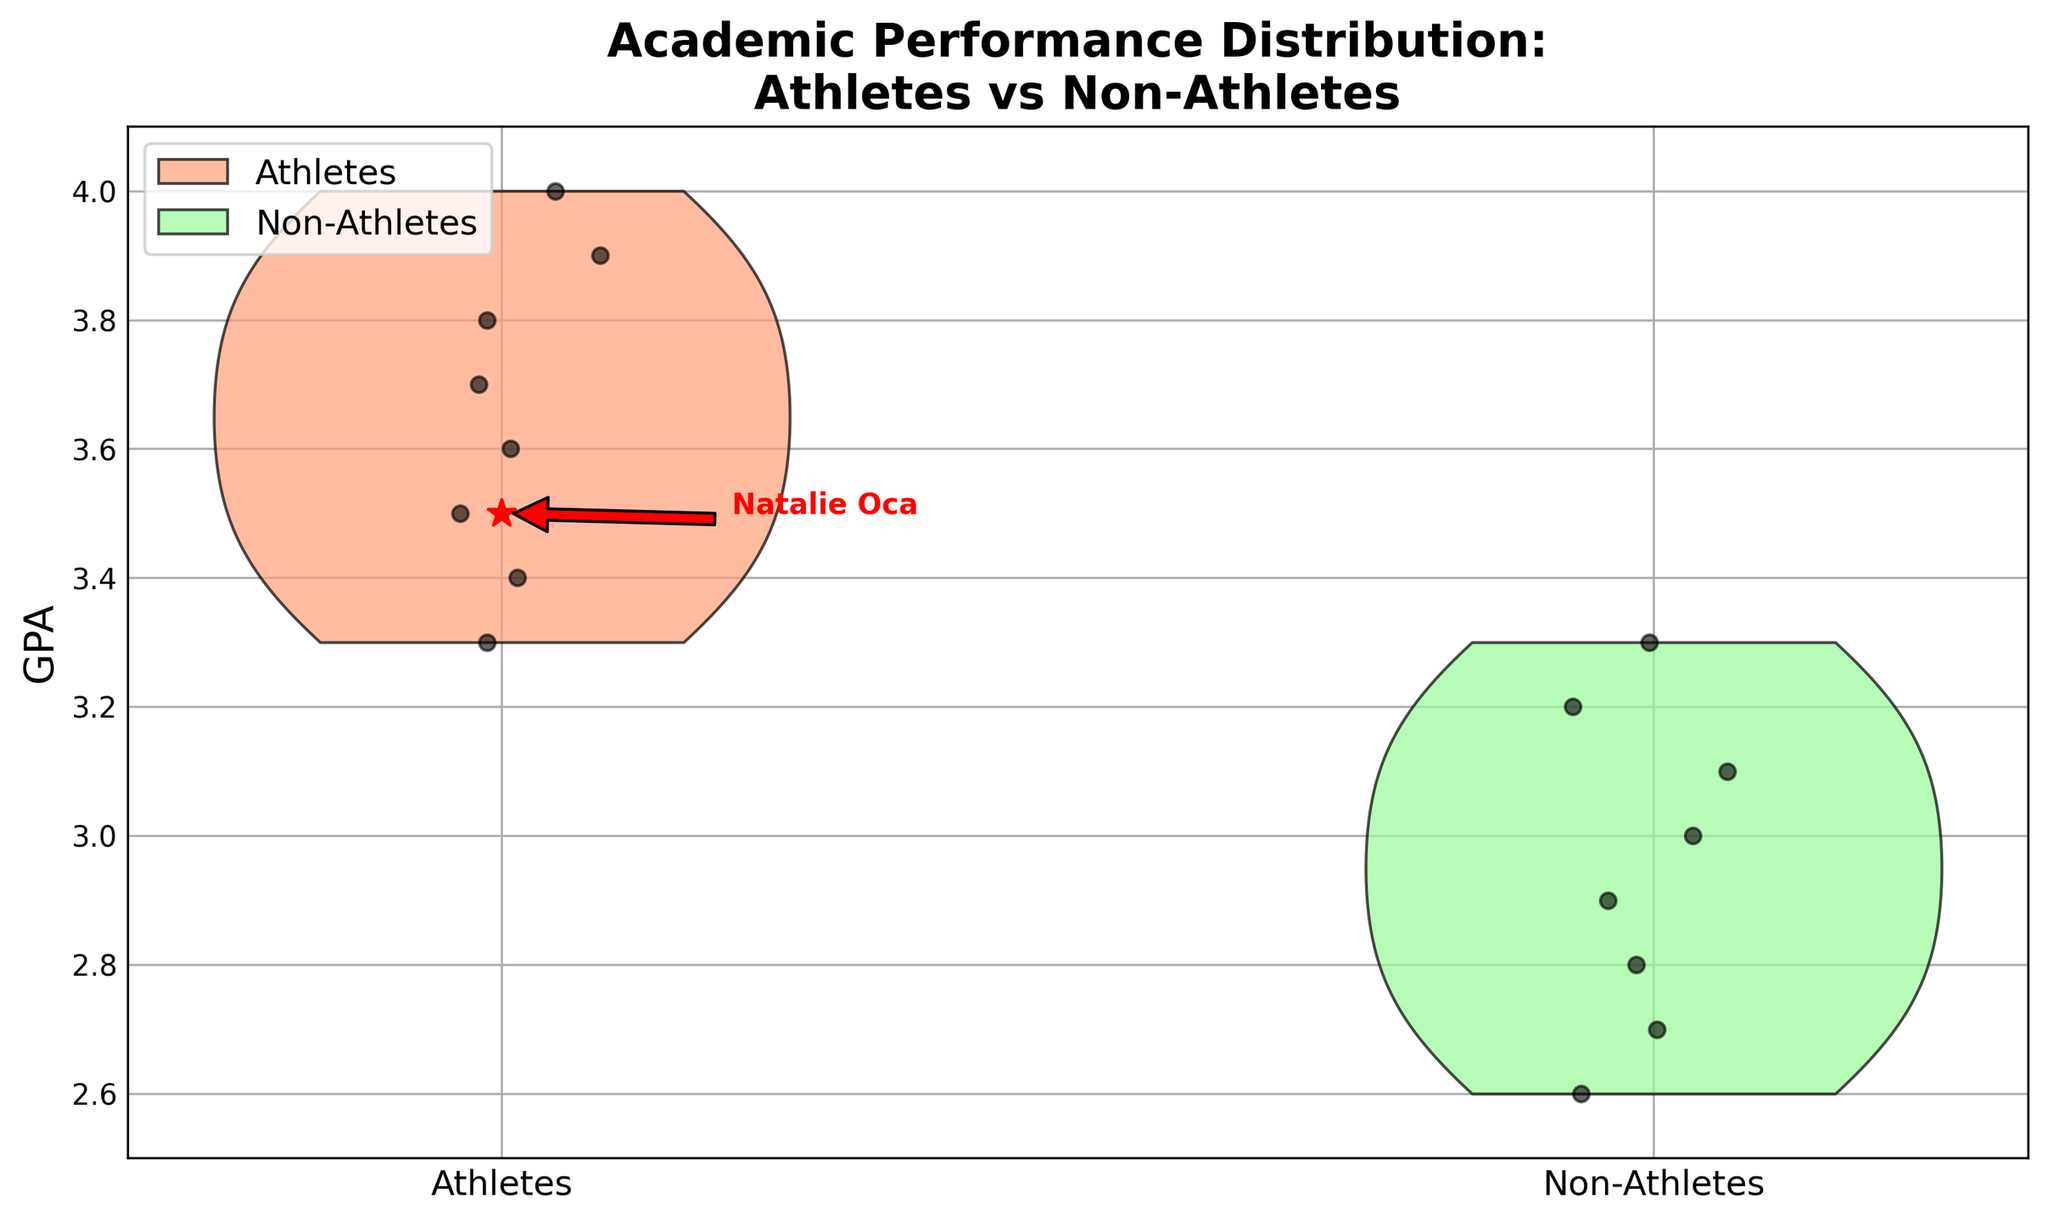what is the title of the figure? The title of the figure is directly shown at the top and reads "Academic Performance Distribution: Athletes vs Non-Athletes".
Answer: Academic Performance Distribution: Athletes vs Non-Athletes What is the range of GPA values displayed in the figure? By examining the y-axis, we see that it ranges from 2.5 to 4.0.
Answer: 2.5 to 4.0 What color represents athletes in the figure? The violin plot for athletes is shown in a color mix of light red/orange with black edges.
Answer: Light red/orange Which group has a higher displayed GPA spread? By observing the width of the violin plots, athletes show a wider and higher GPA spread compared to non-athletes, indicating more distribution.
Answer: Athletes What is Natalie Oca’s GPA? There's a red star scatter representing Natalie Oca in the athlete group at the GPA value of 3.5.
Answer: 3.5 How many non-athletes are included in the figure? We count the individual points within the non-athletes group, summing up to 8.
Answer: 8 Which group has the highest individual GPA? Observing the scatter points' highest value within each group, athletes reach a GPA of 4.0 while non-athletes cap at 3.3. Therefore, athletes have the highest individual GPA of 4.0.
Answer: Athletes Is the median GPA for athletes higher than for non-athletes? The centralized distributions and point densities indicate higher median GPA for athletes compared to non-athletes because the middle values of athletes' GPAs appear higher.
Answer: Yes How do the lowest GPAs between the two groups compare? The lowest GPA for non-athletes is visible at 2.6 while the athletes' lowest GPA is at 3.3. Athletes have a higher minimum GPA.
Answer: Athletes What does the width of the violin plots indicate in this context? The width of the violin plots indicates the density of GPA frequency. Wider sections represent more students having those GPA values.
Answer: Density of GPA Frequency 